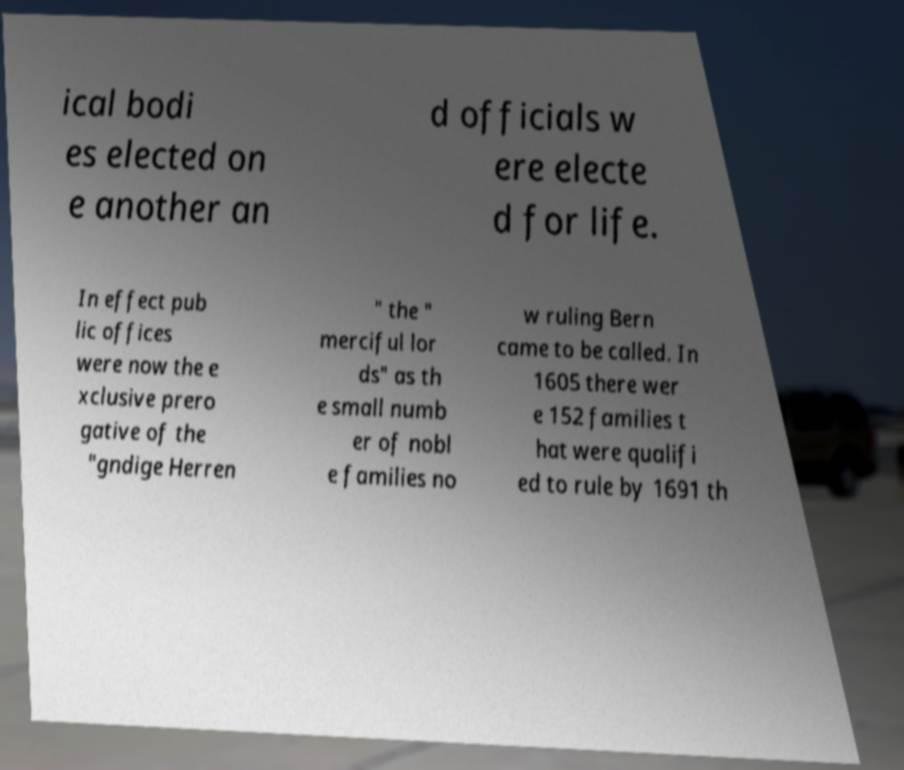Could you assist in decoding the text presented in this image and type it out clearly? ical bodi es elected on e another an d officials w ere electe d for life. In effect pub lic offices were now the e xclusive prero gative of the "gndige Herren " the " merciful lor ds" as th e small numb er of nobl e families no w ruling Bern came to be called. In 1605 there wer e 152 families t hat were qualifi ed to rule by 1691 th 